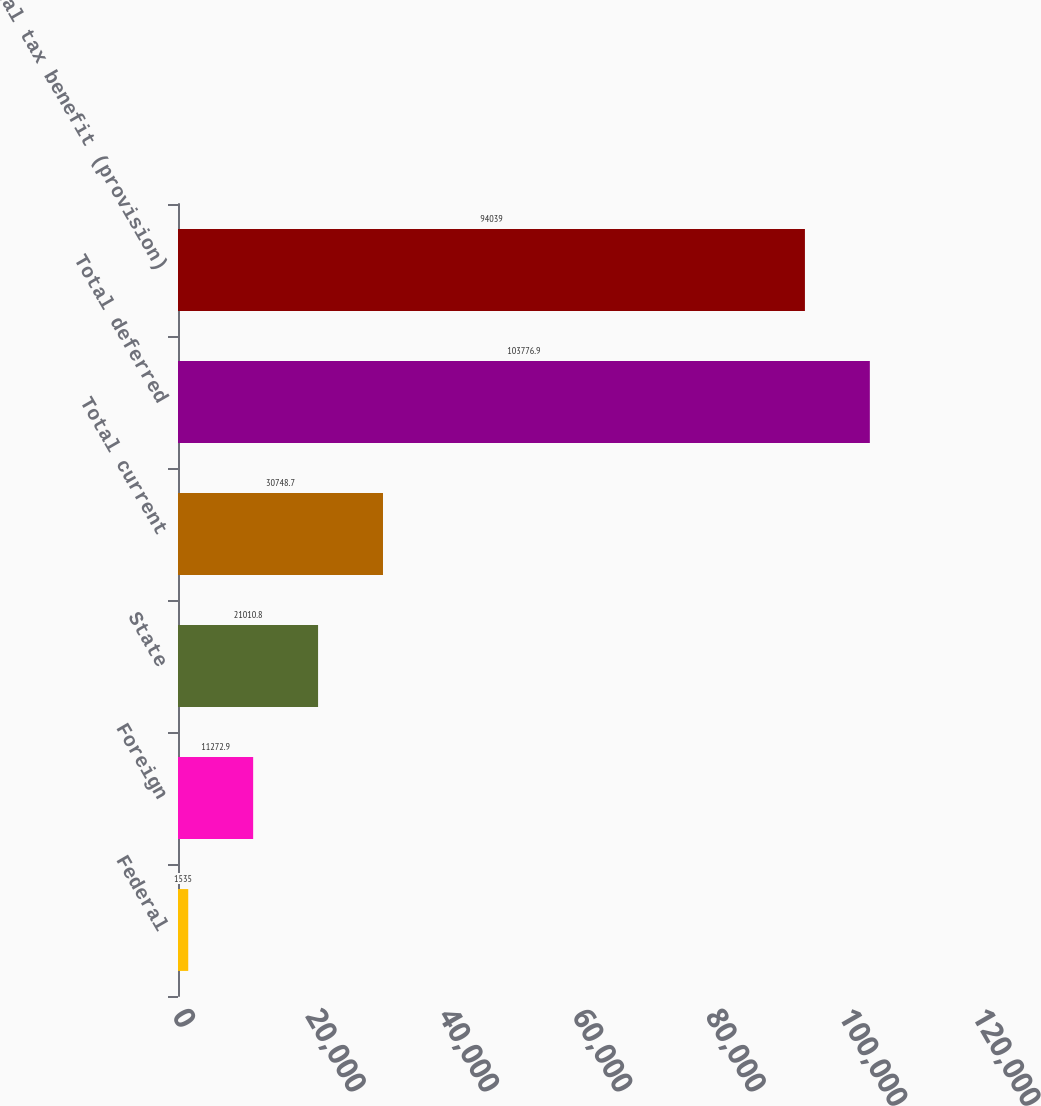Convert chart. <chart><loc_0><loc_0><loc_500><loc_500><bar_chart><fcel>Federal<fcel>Foreign<fcel>State<fcel>Total current<fcel>Total deferred<fcel>Total tax benefit (provision)<nl><fcel>1535<fcel>11272.9<fcel>21010.8<fcel>30748.7<fcel>103777<fcel>94039<nl></chart> 